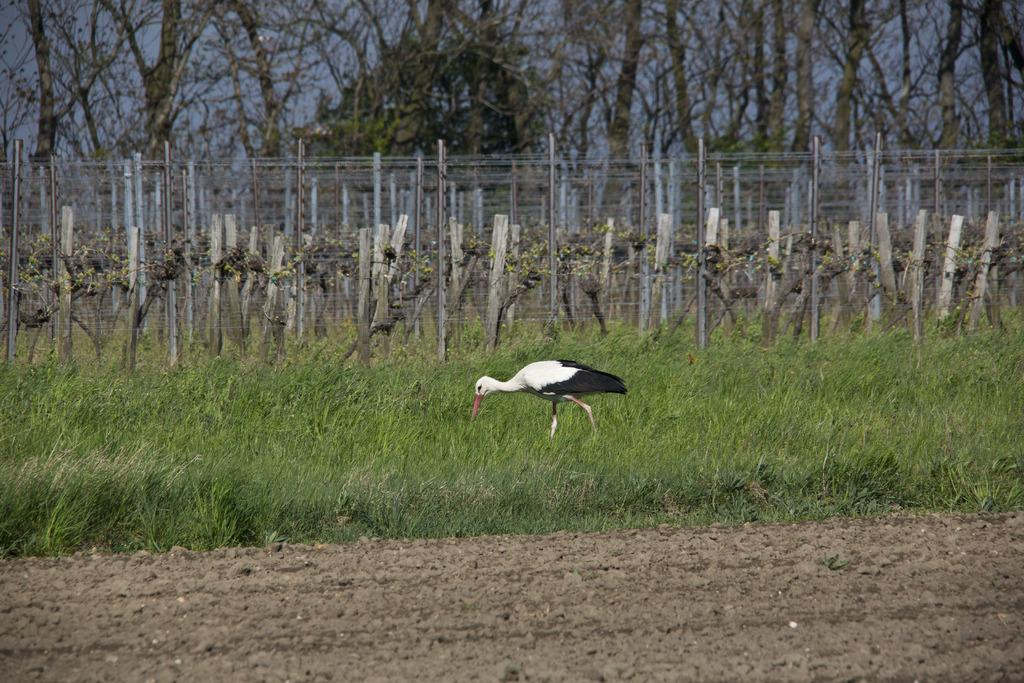What type of vegetation can be seen in the image? There is grass, trees, and plants in the image. What structures are present in the image? There are poles and fences in the image. What is visible at the top of the image? The sky is visible at the top of the image. Can you see any ears in the image? There are no ears present in the image; it features grass, trees, plants, poles, fences, and the sky. Is there any fog visible in the image? There is no fog present in the image; it is clear and shows the sky, vegetation, and structures. 